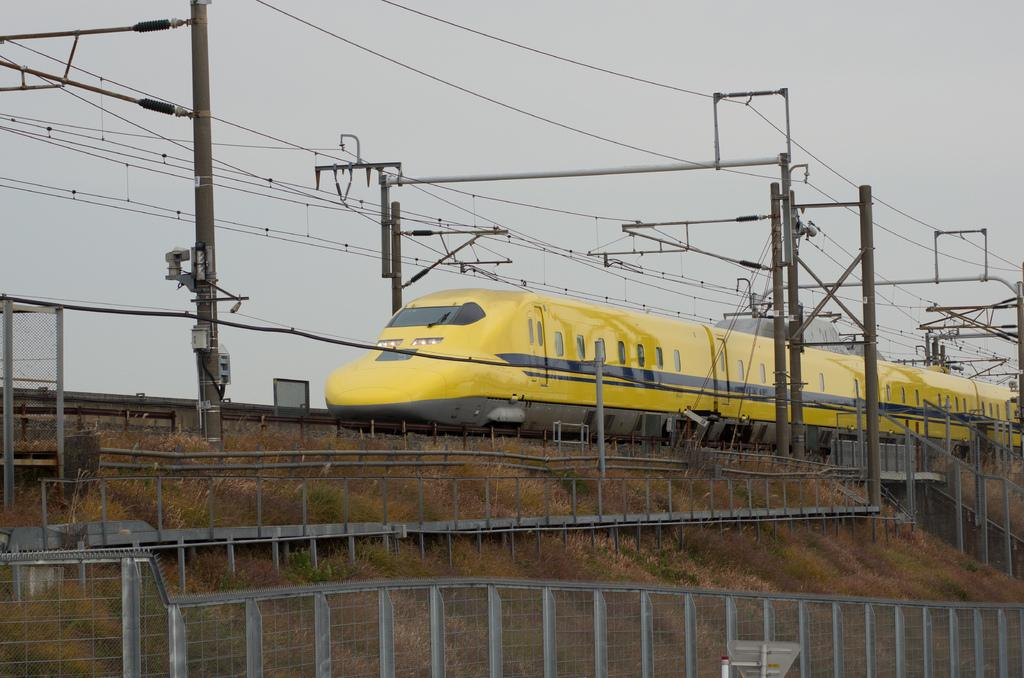What type of vehicle is in the image? There is a yellow color train in the image. What can be seen supporting the wires in the image? There are poles in the image. What are the wires used for in the image? The wires are used for connecting the poles and possibly transmitting electricity. What type of vegetation is present in the image? There is grass in the image. What type of barrier is in the image? There is a fence in the image. What is visible in the background of the image? The sky is visible in the background of the image. What type of curtain can be seen hanging from the train in the image? There is no curtain hanging from the train in the image. What type of structure is visible in the water near the train in the image? There is no water or structure visible in the image; it only features a train, poles, wires, grass, fence, and the sky. 